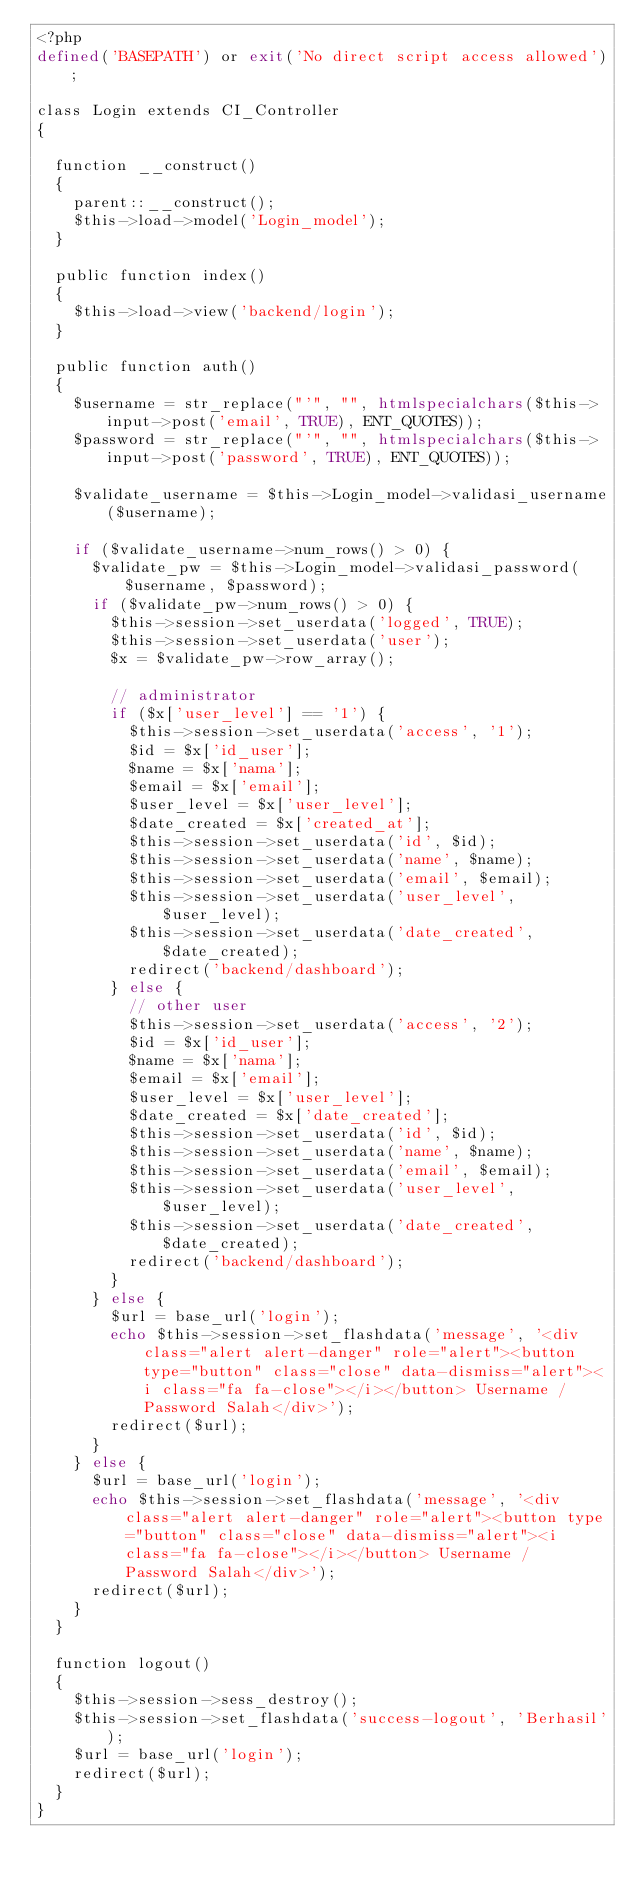Convert code to text. <code><loc_0><loc_0><loc_500><loc_500><_PHP_><?php
defined('BASEPATH') or exit('No direct script access allowed');

class Login extends CI_Controller
{

	function __construct()
	{
		parent::__construct();
		$this->load->model('Login_model');
	}

	public function index()
	{
		$this->load->view('backend/login');
	}

	public function auth()
	{
		$username = str_replace("'", "", htmlspecialchars($this->input->post('email', TRUE), ENT_QUOTES));
		$password = str_replace("'", "", htmlspecialchars($this->input->post('password', TRUE), ENT_QUOTES));

		$validate_username = $this->Login_model->validasi_username($username);

		if ($validate_username->num_rows() > 0) {
			$validate_pw = $this->Login_model->validasi_password($username, $password);
			if ($validate_pw->num_rows() > 0) {
				$this->session->set_userdata('logged', TRUE);
				$this->session->set_userdata('user');
				$x = $validate_pw->row_array();

				// administrator
				if ($x['user_level'] == '1') {
					$this->session->set_userdata('access', '1');
					$id = $x['id_user'];
					$name = $x['nama'];
					$email = $x['email'];
					$user_level = $x['user_level'];
					$date_created = $x['created_at'];
					$this->session->set_userdata('id', $id);
					$this->session->set_userdata('name', $name);
					$this->session->set_userdata('email', $email);
					$this->session->set_userdata('user_level', $user_level);
					$this->session->set_userdata('date_created', $date_created);
					redirect('backend/dashboard');
				} else {
					// other user
					$this->session->set_userdata('access', '2');
					$id = $x['id_user'];
					$name = $x['nama'];
					$email = $x['email'];
					$user_level = $x['user_level'];
					$date_created = $x['date_created'];
					$this->session->set_userdata('id', $id);
					$this->session->set_userdata('name', $name);
					$this->session->set_userdata('email', $email);
					$this->session->set_userdata('user_level', $user_level);
					$this->session->set_userdata('date_created', $date_created);
					redirect('backend/dashboard');
				}
			} else {
				$url = base_url('login');
				echo $this->session->set_flashdata('message', '<div class="alert alert-danger" role="alert"><button type="button" class="close" data-dismiss="alert"><i class="fa fa-close"></i></button> Username / Password Salah</div>');
				redirect($url);
			}
		} else {
			$url = base_url('login');
			echo $this->session->set_flashdata('message', '<div class="alert alert-danger" role="alert"><button type="button" class="close" data-dismiss="alert"><i class="fa fa-close"></i></button> Username / Password Salah</div>');
			redirect($url);
		}
	}

	function logout()
	{
		$this->session->sess_destroy();
		$this->session->set_flashdata('success-logout', 'Berhasil');
		$url = base_url('login');
		redirect($url);
	}
}
</code> 